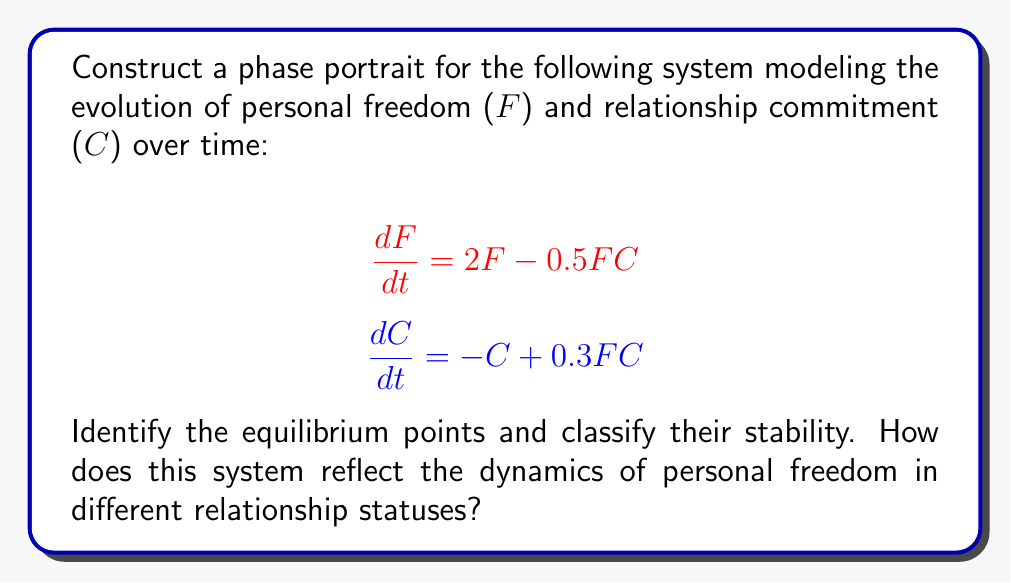Can you solve this math problem? 1. Find the equilibrium points by setting $\frac{dF}{dt} = 0$ and $\frac{dC}{dt} = 0$:

   $2F - 0.5FC = 0$
   $-C + 0.3FC = 0$

2. Solve the system:
   a) $(0, 0)$ is a trivial equilibrium point.
   b) From the second equation: $C(0.3F - 1) = 0$, so $F = \frac{10}{3}$ or $C = 0$.
   c) Substituting $F = \frac{10}{3}$ into the first equation: $2(\frac{10}{3}) - 0.5(\frac{10}{3})C = 0$
      Solving for $C$: $C = \frac{40}{5} = 8$

   Therefore, the equilibrium points are $(0, 0)$ and $(\frac{10}{3}, 8)$.

3. Analyze stability by finding the Jacobian matrix:

   $$J = \begin{bmatrix}
   2 - 0.5C & -0.5F \\
   0.3C & -1 + 0.3F
   \end{bmatrix}$$

4. Evaluate at $(0, 0)$:

   $$J_{(0,0)} = \begin{bmatrix}
   2 & 0 \\
   0 & -1
   \end{bmatrix}$$

   Eigenvalues: $\lambda_1 = 2$, $\lambda_2 = -1$
   This is a saddle point (unstable).

5. Evaluate at $(\frac{10}{3}, 8)$:

   $$J_{(\frac{10}{3}, 8)} = \begin{bmatrix}
   -2 & -\frac{5}{3} \\
   2.4 & 0
   \end{bmatrix}$$

   Eigenvalues: $\lambda_{1,2} = -1 \pm i\sqrt{3}$
   This is a stable spiral point.

6. Sketch the phase portrait:

[asy]
import graph;
size(200);
xaxis("F", Arrow);
yaxis("C", Arrow);

void vector(real x, real y) {
  real dx = 2*x - 0.5*x*y;
  real dy = -y + 0.3*x*y;
  real l = 0.15/sqrt(dx^2+dy^2);
  draw((x,y)--(x+l*dx,y+l*dy),Arrow);
}

for(int i = -1; i <= 4; ++i)
  for(int j = -1; j <= 9; ++j)
    vector(i,j);

dot((0,0));
dot((10/3,8));
label("(0,0)", (0,0), SW);
label("(10/3,8)", (10/3,8), NE);
[/asy]

The phase portrait shows:
- The origin (0,0) is a saddle point, representing a state of no commitment and no personal freedom.
- The point (10/3,8) is a stable spiral, representing a balanced state of high personal freedom and commitment.
- Trajectories starting with low commitment tend to increase in personal freedom before potentially spiraling towards the stable point.
- This system reflects that personal freedom can coexist with commitment in a balanced relationship, contrary to the persona's belief that marriage limits freedom.
Answer: Phase portrait with saddle point at (0,0) and stable spiral at (10/3,8); trajectories show increasing freedom before balancing with commitment. 